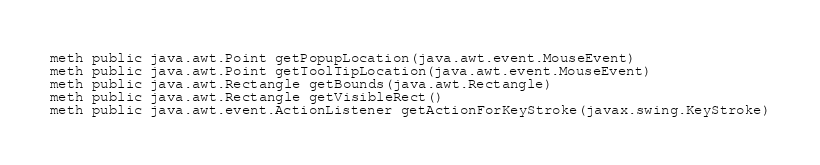Convert code to text. <code><loc_0><loc_0><loc_500><loc_500><_SML_>meth public java.awt.Point getPopupLocation(java.awt.event.MouseEvent)
meth public java.awt.Point getToolTipLocation(java.awt.event.MouseEvent)
meth public java.awt.Rectangle getBounds(java.awt.Rectangle)
meth public java.awt.Rectangle getVisibleRect()
meth public java.awt.event.ActionListener getActionForKeyStroke(javax.swing.KeyStroke)</code> 